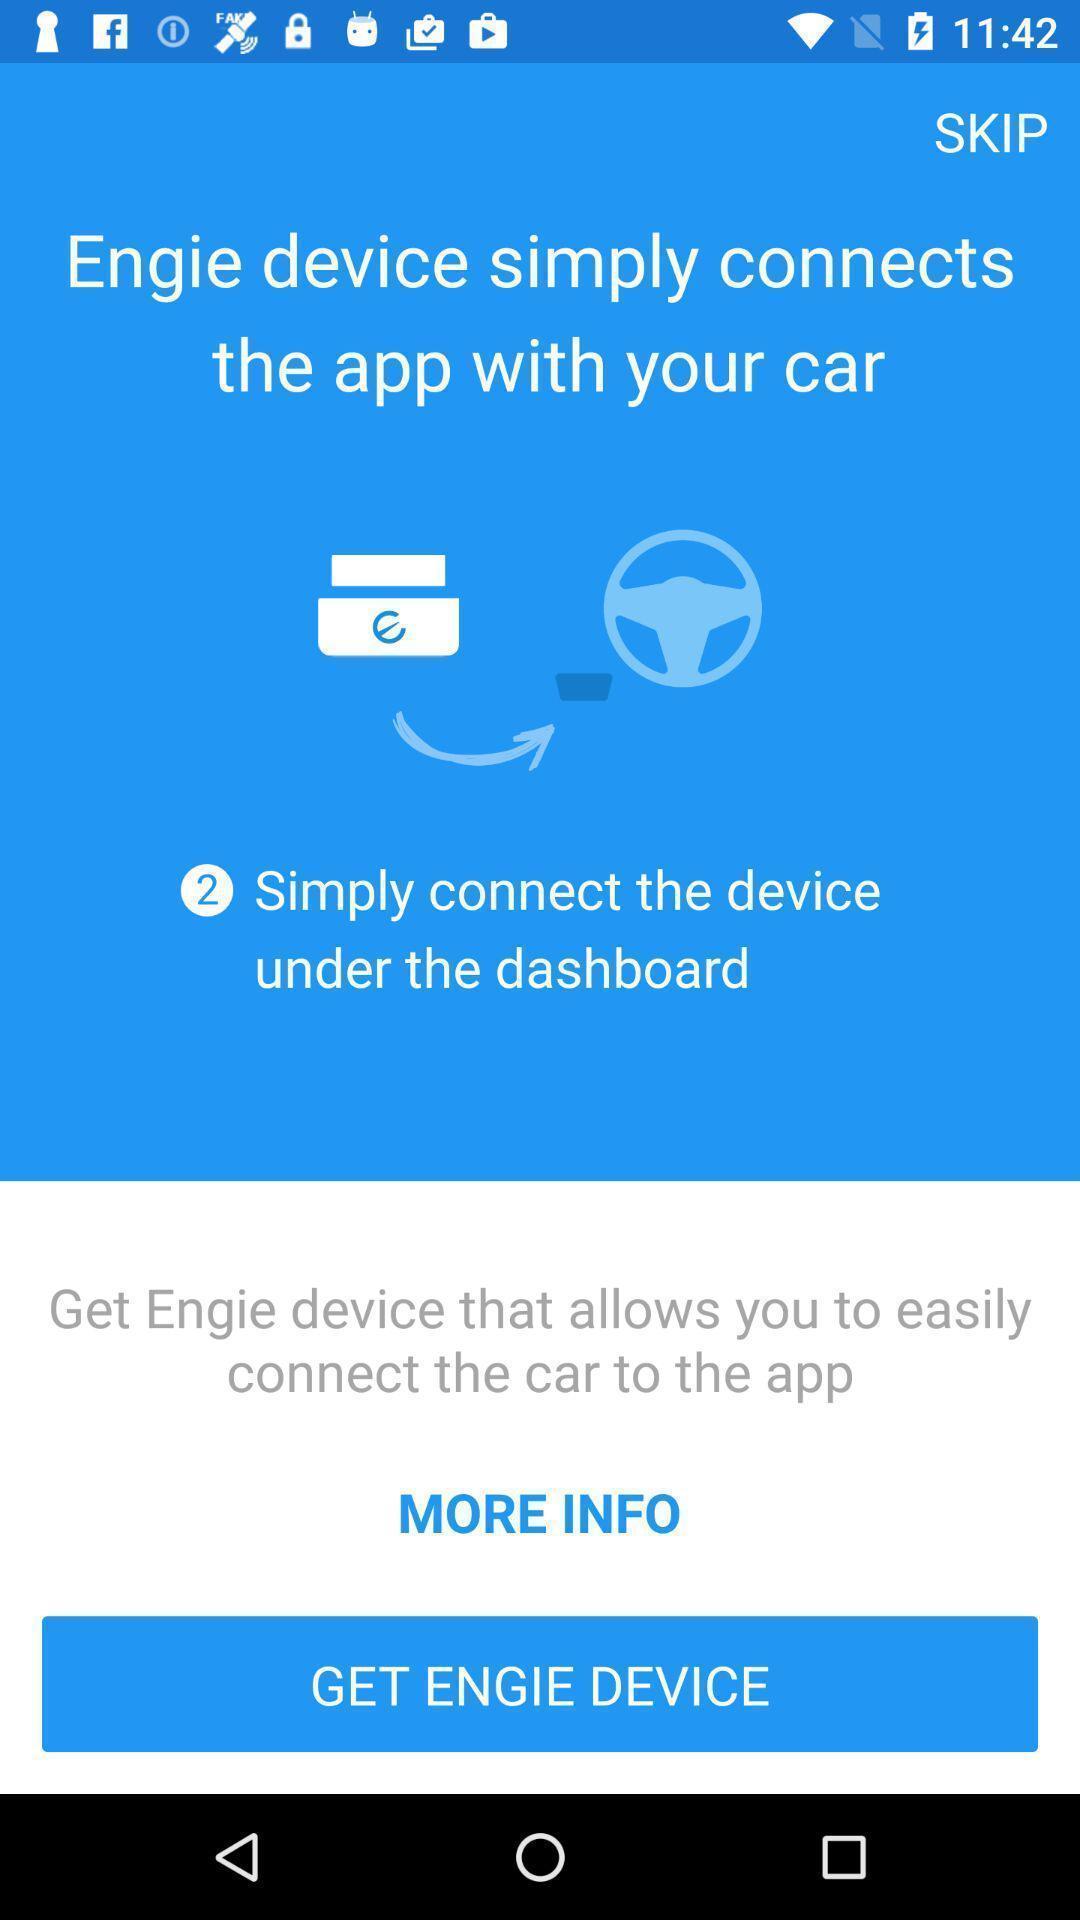Provide a textual representation of this image. Page requesting to get a device on an app. 